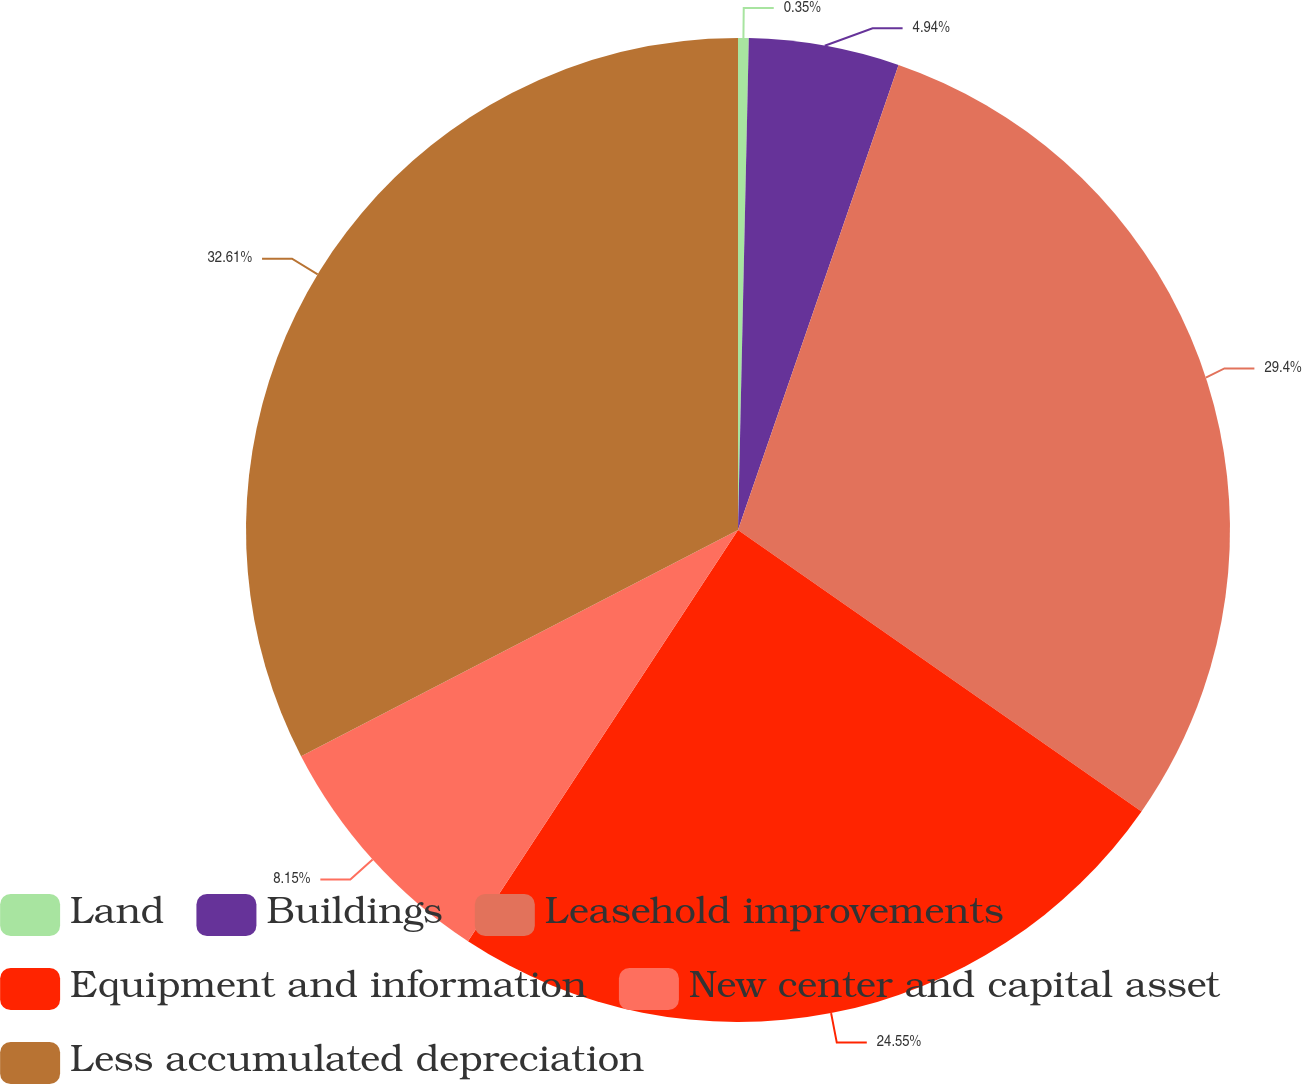Convert chart to OTSL. <chart><loc_0><loc_0><loc_500><loc_500><pie_chart><fcel>Land<fcel>Buildings<fcel>Leasehold improvements<fcel>Equipment and information<fcel>New center and capital asset<fcel>Less accumulated depreciation<nl><fcel>0.35%<fcel>4.94%<fcel>29.4%<fcel>24.55%<fcel>8.15%<fcel>32.6%<nl></chart> 